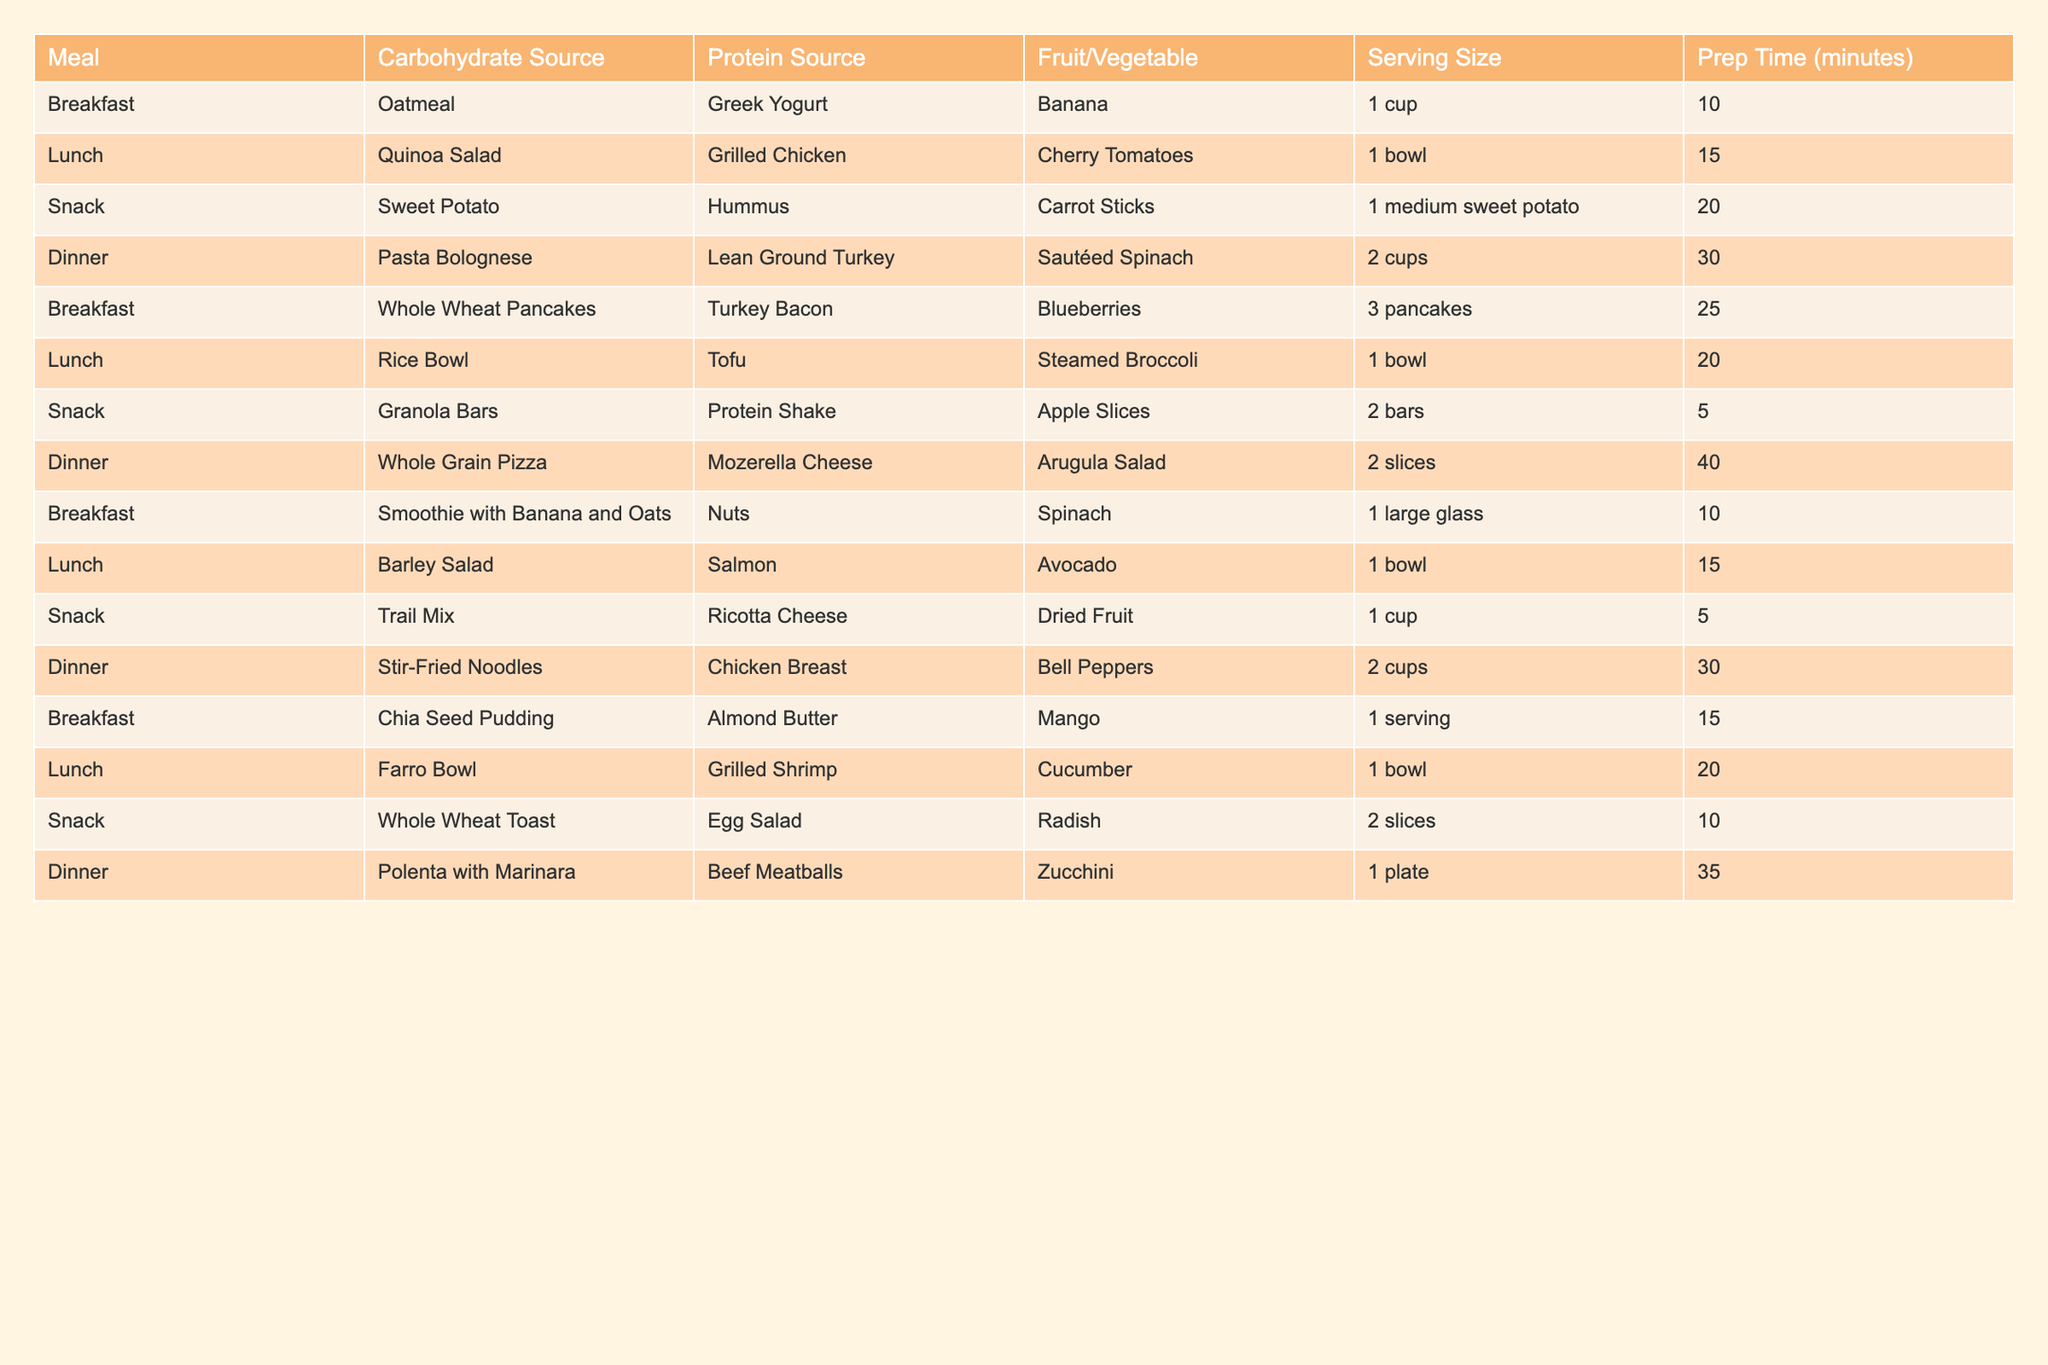What is the protein source for the breakfast meal? The breakfast meal lists oatmeal as the carbohydrate source and Greek yogurt as the protein source in the table.
Answer: Greek yogurt Which dinner contains a vegetable from the table? The table lists multiple dinners, including Pasta Bolognese with sautéed spinach and Polenta with Marinara with zucchini, both of which include vegetables.
Answer: Yes How long does it take to prepare the lunch option with grilled chicken? The lunch option with grilled chicken, which is a quinoa salad, takes 15 minutes to prepare according to the table.
Answer: 15 minutes What are the serving sizes for the snack option that includes granola bars? The snack option that includes granola bars lists the serving size as 2 bars in the table.
Answer: 2 bars How many total servings are there for the dinner options? The dinner options include Pasta Bolognese (2 cups), Whole Grain Pizza (2 slices), and Stir-Fried Noodles (2 cups). If we sum the serving sizes, we get 2 + 2 + 2 = 6 total servings.
Answer: 6 servings Which snack option has the shortest prep time? The snack option that lists the shortest prep time is the granola bars, which only take 5 minutes to prepare, compared to other options with longer times.
Answer: 5 minutes Is there a vegetable included in every meal? By examining the table, some meals do not include a vegetable; for example, breakfast options do not have a vegetable listed. Therefore, not every meal contains a vegetable.
Answer: No If I combine the prep times for all breakfast options, what is the total? The prep times for the breakfast options are 10 minutes for oatmeal, 25 minutes for pancakes, 10 minutes for the smoothie, and 15 minutes for chia pudding. Summing these gives 10 + 25 + 10 + 15 = 60 minutes total.
Answer: 60 minutes What is the carbohydrate source in the lunch option that includes salmon? The lunch option that includes salmon lists barley salad as the carbohydrate source in the table.
Answer: Barley salad Which meal has the highest prep time and how long is it? The dinner option for Whole Grain Pizza has the highest prep time of 40 minutes when compared to other meals listed in the table.
Answer: 40 minutes 